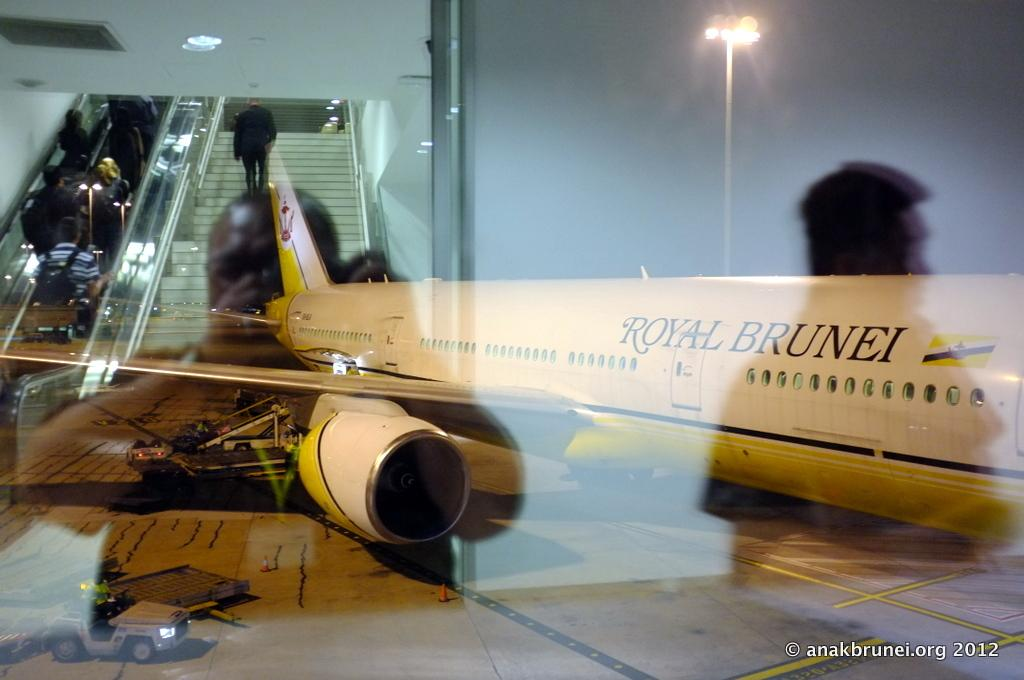<image>
Offer a succinct explanation of the picture presented. A person taking a picture at an airport of a Royal Brunei plane 